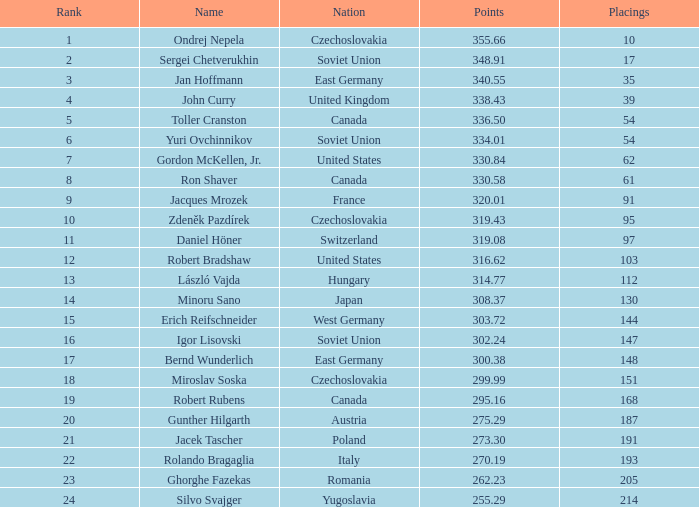38 points? East Germany. 